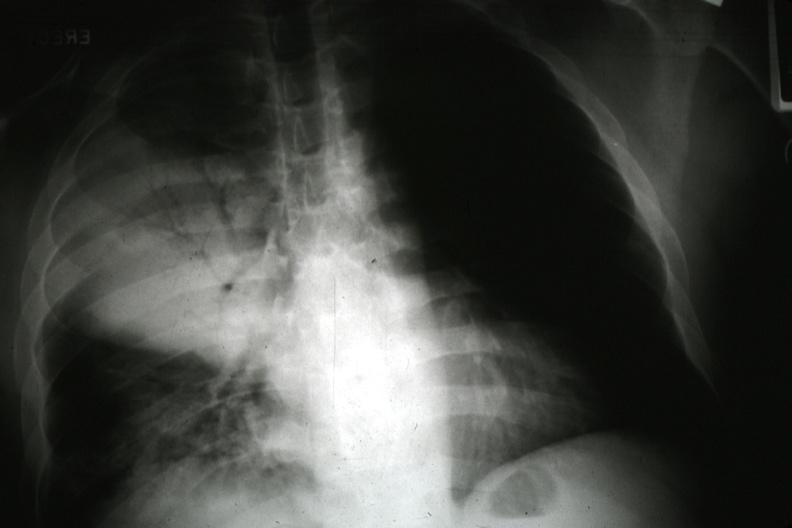s spinal column present?
Answer the question using a single word or phrase. No 